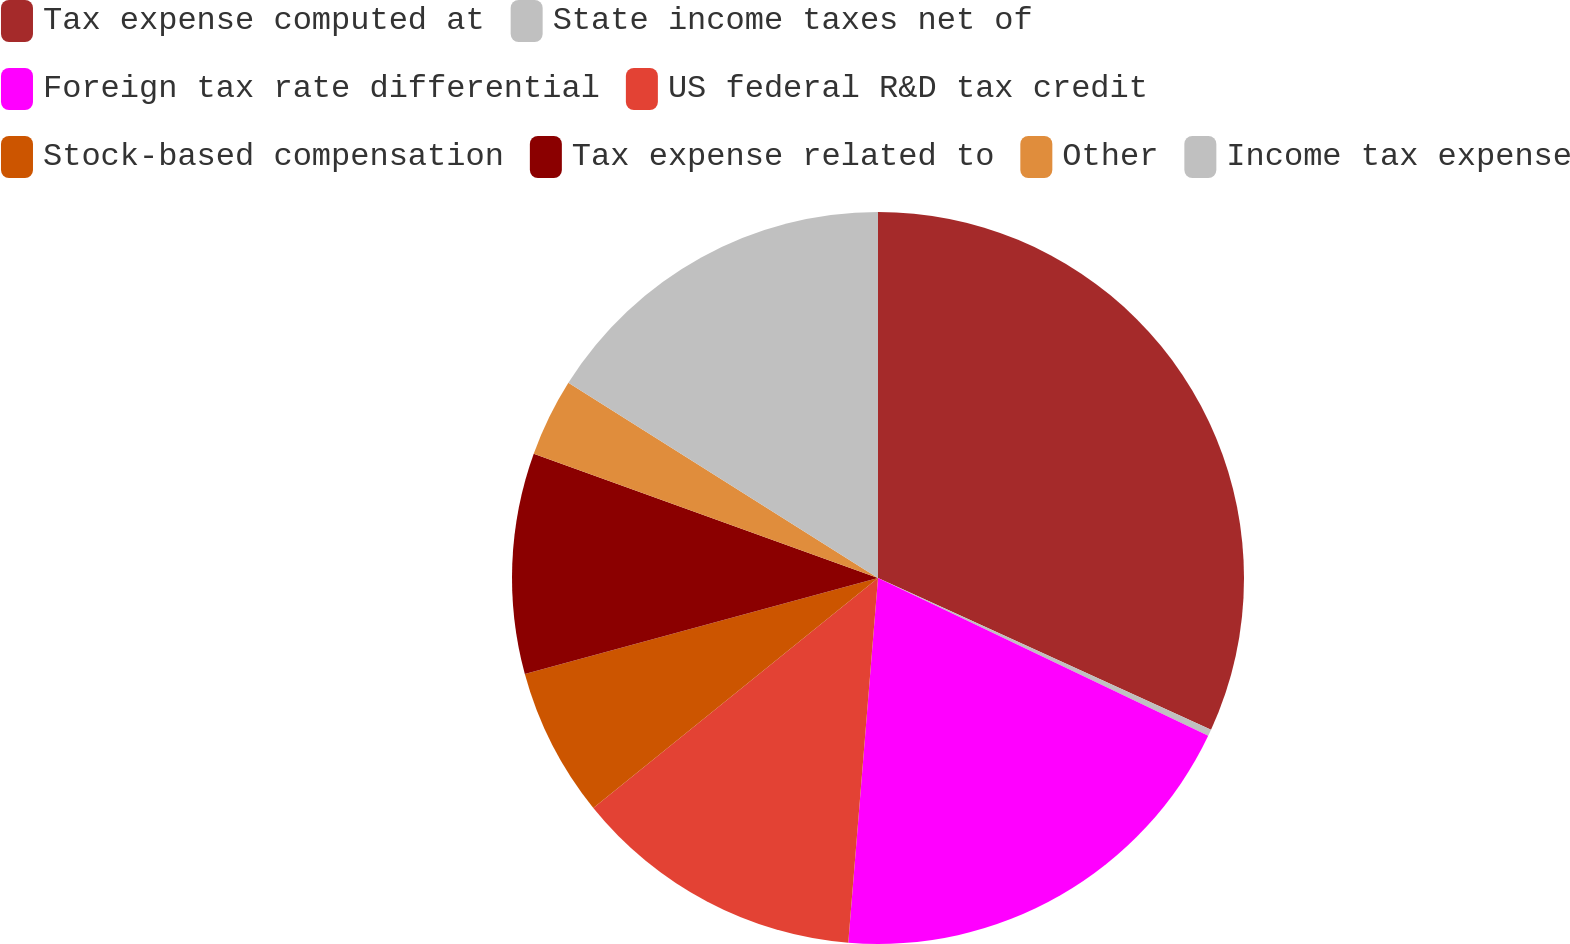Convert chart. <chart><loc_0><loc_0><loc_500><loc_500><pie_chart><fcel>Tax expense computed at<fcel>State income taxes net of<fcel>Foreign tax rate differential<fcel>US federal R&D tax credit<fcel>Stock-based compensation<fcel>Tax expense related to<fcel>Other<fcel>Income tax expense<nl><fcel>31.81%<fcel>0.29%<fcel>19.2%<fcel>12.89%<fcel>6.59%<fcel>9.74%<fcel>3.44%<fcel>16.05%<nl></chart> 